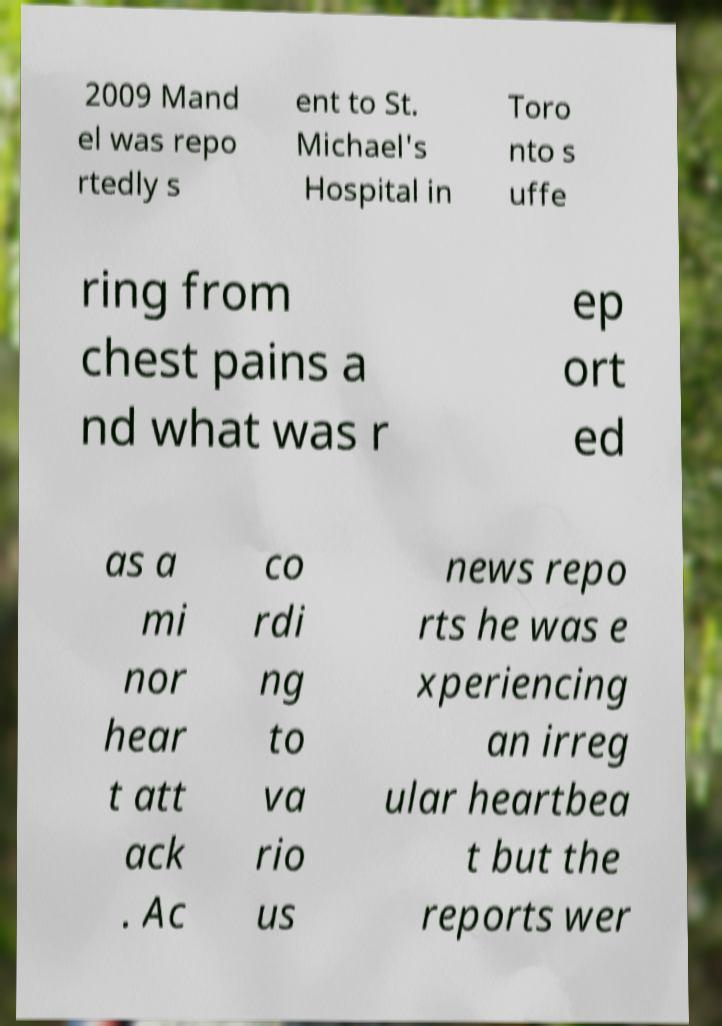Can you accurately transcribe the text from the provided image for me? 2009 Mand el was repo rtedly s ent to St. Michael's Hospital in Toro nto s uffe ring from chest pains a nd what was r ep ort ed as a mi nor hear t att ack . Ac co rdi ng to va rio us news repo rts he was e xperiencing an irreg ular heartbea t but the reports wer 